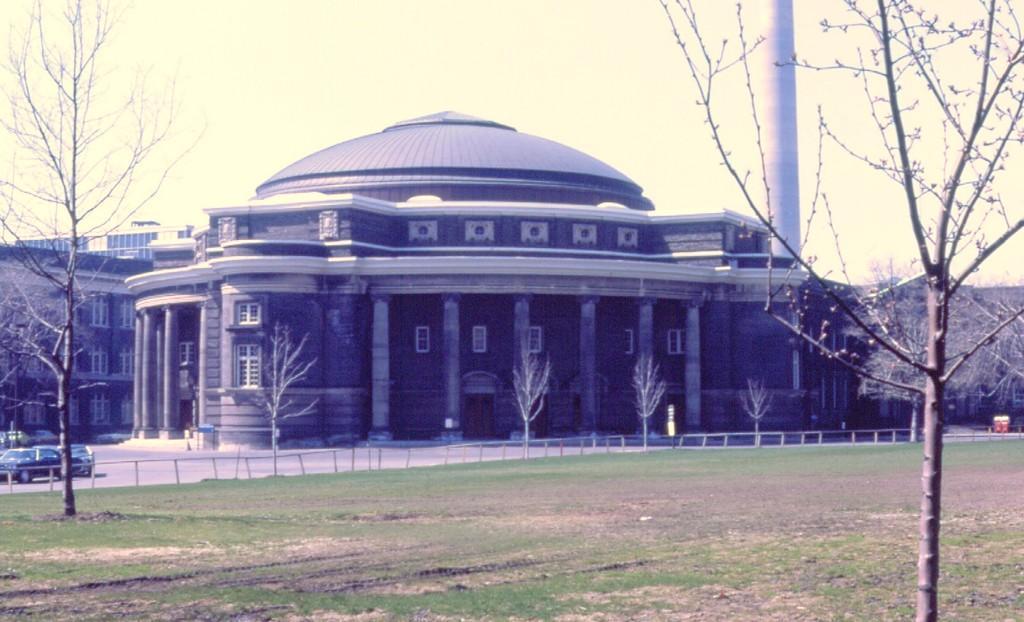Could you give a brief overview of what you see in this image? In this picture I can see there is a road, there are few vehicles on the left side, there is a building and it has pillars, windows, trees. There is a huge pole on right side and the sky is clear. 